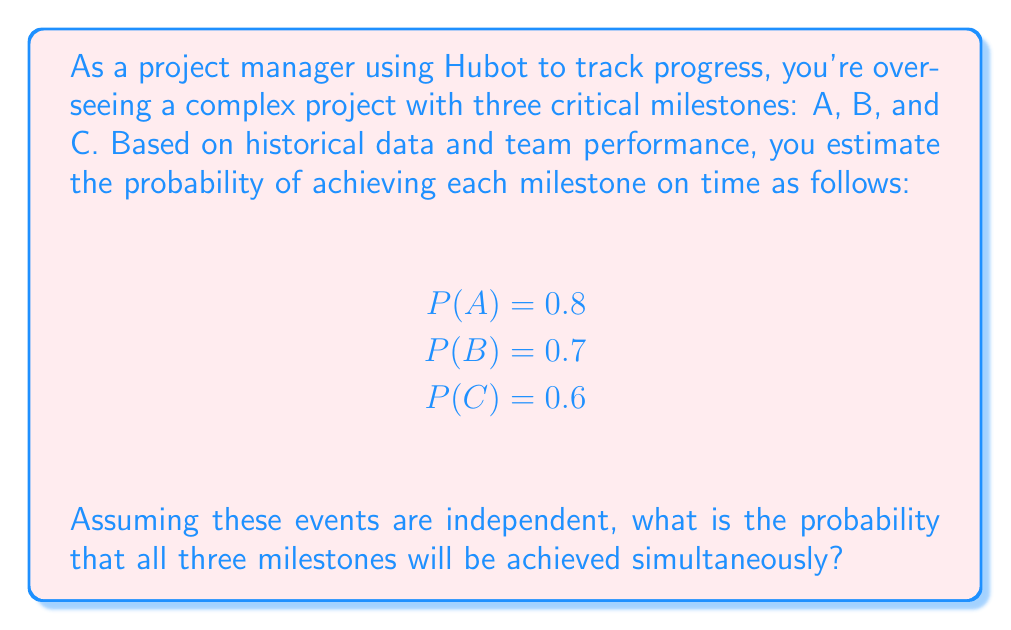Give your solution to this math problem. To solve this problem, we'll use the concept of joint probability for independent events. When events are independent, the probability of all of them occurring simultaneously is the product of their individual probabilities.

Step 1: Identify the probabilities of each event
P(A) = 0.8
P(B) = 0.7
P(C) = 0.6

Step 2: Apply the joint probability formula for independent events
For independent events, the joint probability is:

$$P(A \cap B \cap C) = P(A) \times P(B) \times P(C)$$

Step 3: Substitute the values and calculate
$$P(A \cap B \cap C) = 0.8 \times 0.7 \times 0.6$$

Step 4: Perform the multiplication
$$P(A \cap B \cap C) = 0.336$$

Therefore, the probability of all three milestones being achieved simultaneously is 0.336 or 33.6%.
Answer: 0.336 